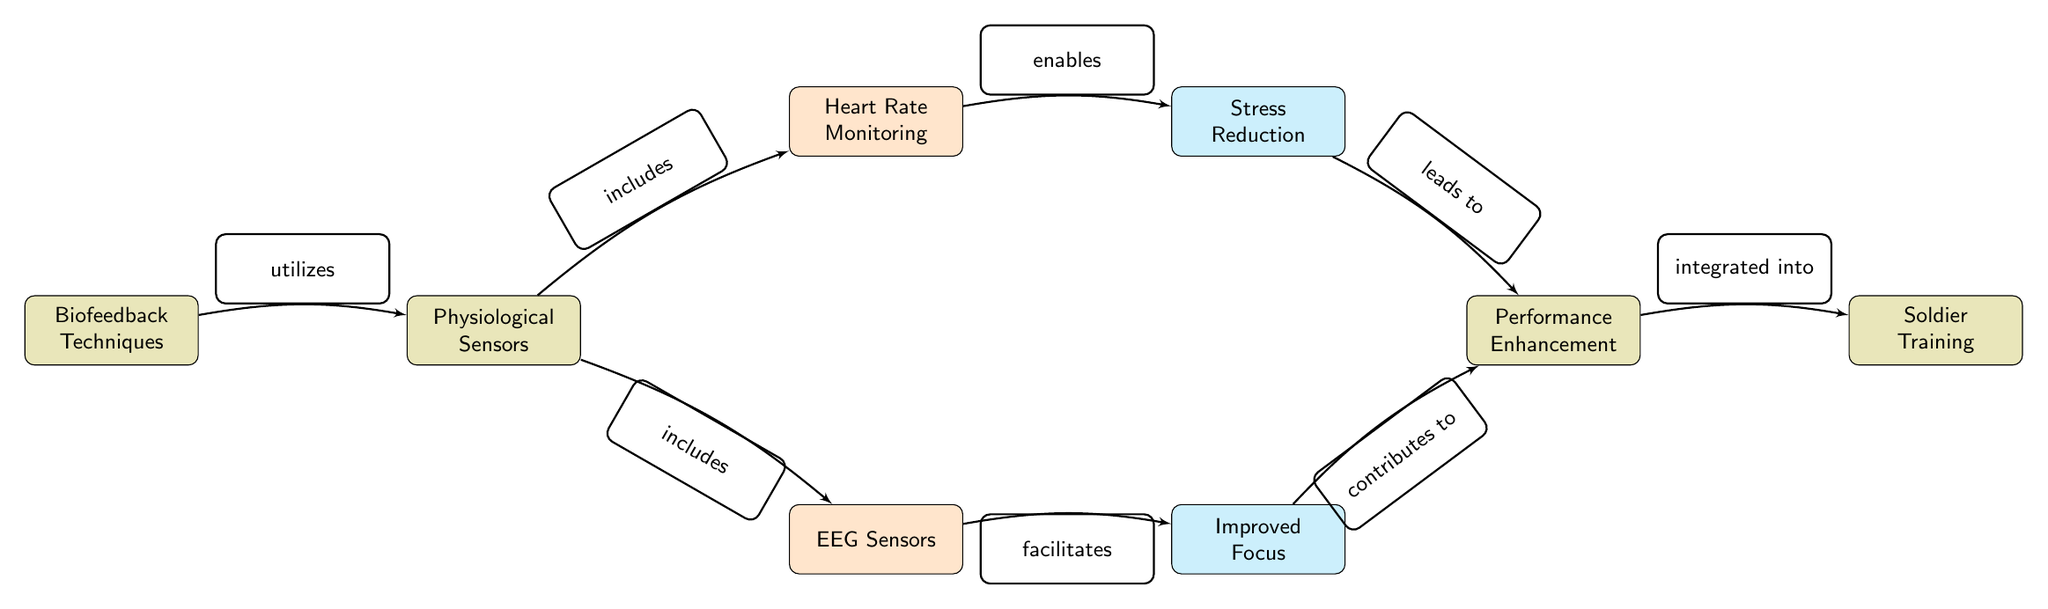What is the main focus of the diagram? The diagram visually represents the relationship and flow between biofeedback techniques, physiological sensors, and their effects on soldier performance. The central focus is to enhance soldier performance under stressful conditions through the integration of these elements.
Answer: Biofeedback Techniques How many physiological sensors are included in the diagram? The diagram indicates two physiological sensors: Heart Rate Monitoring and EEG Sensors. This can be counted by observing the relevant nodes branching from the "Physiological Sensors" node.
Answer: 2 What effect does Heart Rate Monitoring enable? Heart Rate Monitoring directly leads to the effect of Stress Reduction, as shown in the arrow connecting the HRM node to the SR node in the diagram.
Answer: Stress Reduction What two contributions lead to Performance Enhancement? The diagram illustrates that Stress Reduction and Improved Focus both contribute to Performance Enhancement. This is evident from the arrows pointing to the Performance Enhancement node from the respective effect nodes.
Answer: Stress Reduction, Improved Focus What is integrated into Soldier Training? The diagram specifies that Performance Enhancement is integrated into Soldier Training. This relationship is highlighted by the arrow connecting the Performance Enhancement node to the Soldier Training node.
Answer: Performance Enhancement Which biofeedback technique utilizes physiological sensors? The diagram indicates that Biofeedback Techniques utilize Physiological Sensors, explicitly connected by an arrow from the Biofeedback Techniques node to the Physiological Sensors node.
Answer: Physiological Sensors Which effect is facilitated by EEG Sensors? According to the diagram, EEG Sensors facilitate Improved Focus, as indicated by the arrow from the EEG node leading to the Improved Focus node.
Answer: Improved Focus What is the direction of the flow from Physiological Sensors to Biofeedback Techniques? The arrow indicates that Biofeedback Techniques utilize Physiological Sensors, showing that the flow moves from Physiological Sensors back to Biofeedback Techniques, which also means that Physiological Sensors serve as a foundation for applying biofeedback methods.
Answer: Utilizes 